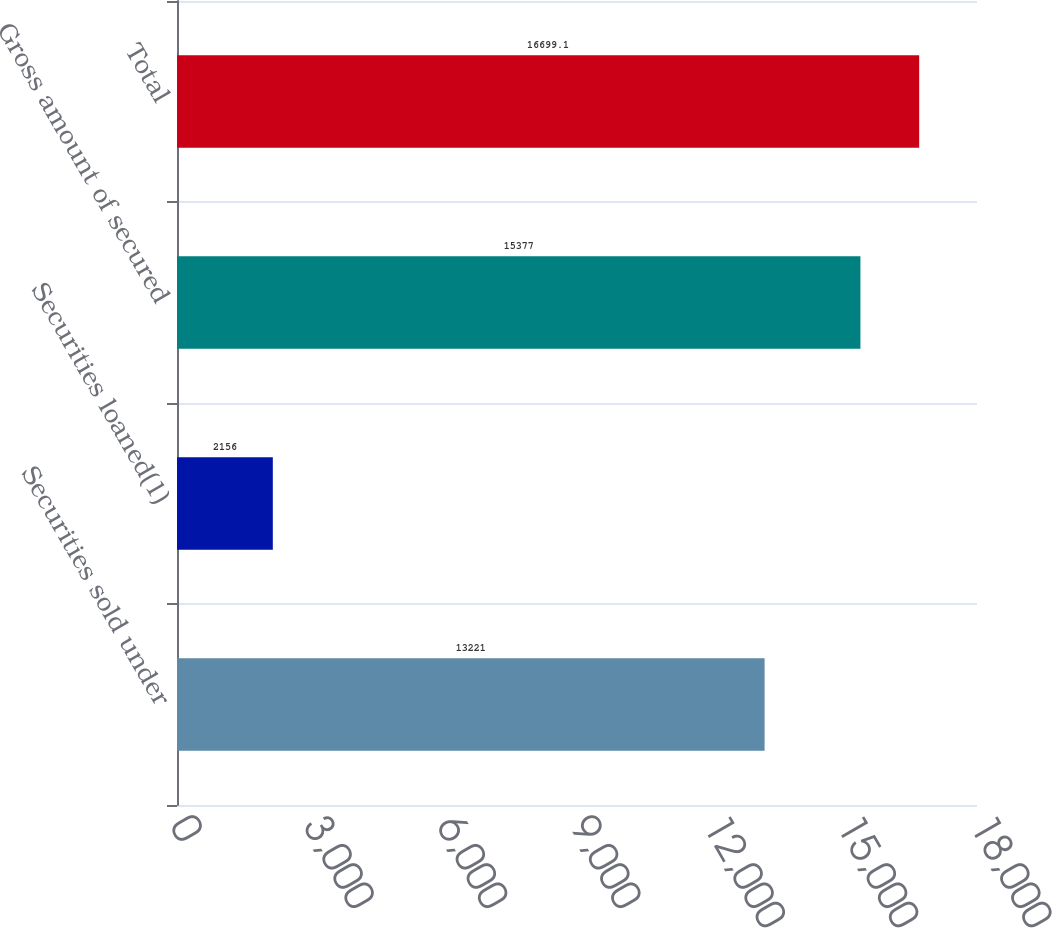Convert chart to OTSL. <chart><loc_0><loc_0><loc_500><loc_500><bar_chart><fcel>Securities sold under<fcel>Securities loaned(1)<fcel>Gross amount of secured<fcel>Total<nl><fcel>13221<fcel>2156<fcel>15377<fcel>16699.1<nl></chart> 